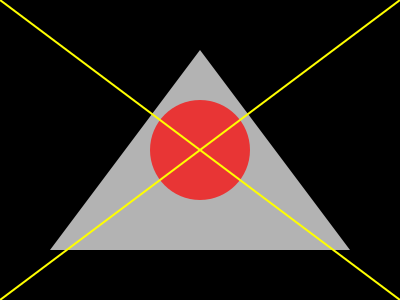Analyze the visual composition of this still frame from Alfred Hitchcock's "Vertigo" (1958). How does the use of geometric shapes and lines contribute to the film's themes of obsession and psychological instability? 1. Triangle: The dominant white triangle in the center represents instability and tension. Its inverted position suggests a lack of balance, mirroring the protagonist's psychological state.

2. Circle: The red circle at the center symbolizes obsession and fixation. Its position within the triangle creates a focal point, drawing the viewer's attention.

3. Diagonal lines: The yellow diagonal lines crossing the frame create a sense of dynamism and disorientation. They intersect at the center of the circle, emphasizing the central theme of spiraling obsession.

4. Contrast: The stark contrast between the black background and white triangle creates a sense of unease and visual tension.

5. Symmetry and asymmetry: While the overall composition is symmetrical, the asymmetrical placement of the circle within the triangle adds to the feeling of imbalance.

6. Color symbolism: The use of red for the circle suggests danger or passion, while the yellow lines evoke caution or madness.

This composition visually represents the film's themes by creating a sense of instability, focus on a central obsession, and overall psychological tension through geometric shapes and lines.
Answer: Geometric shapes and lines create visual instability and focus on obsession, mirroring the film's psychological themes. 